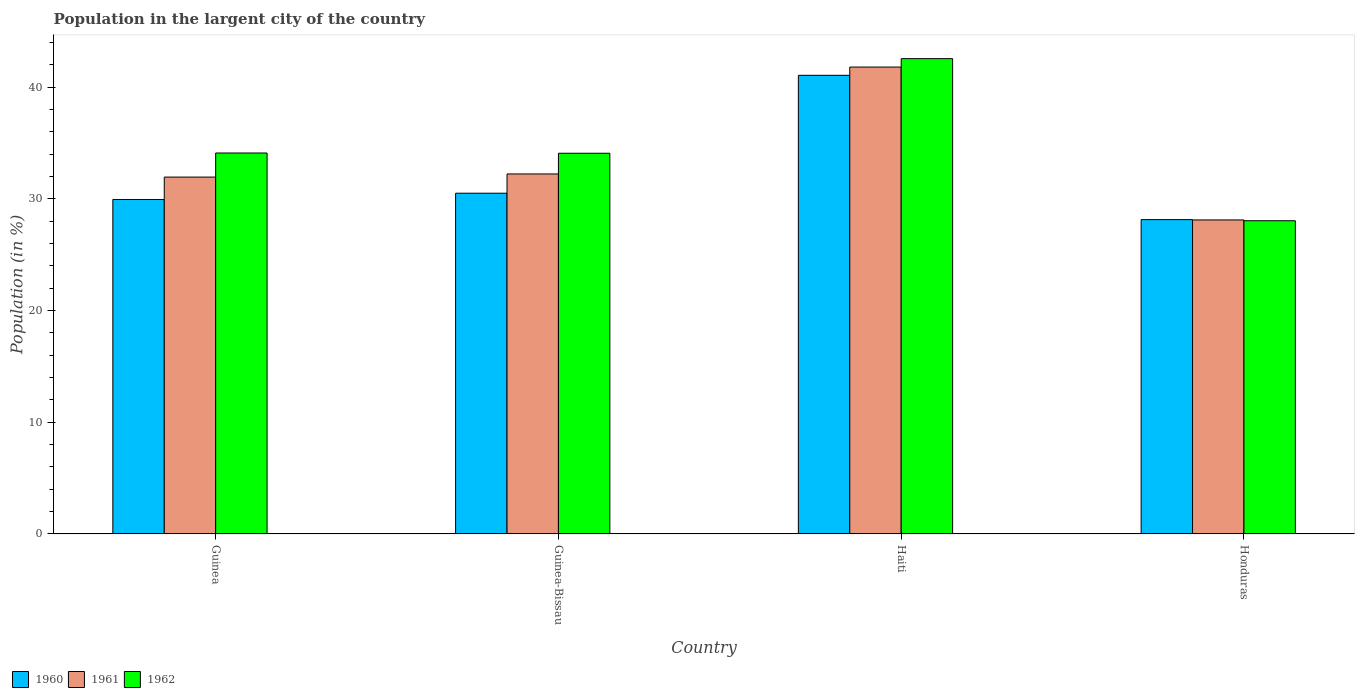Are the number of bars on each tick of the X-axis equal?
Offer a terse response. Yes. How many bars are there on the 1st tick from the left?
Your response must be concise. 3. What is the label of the 4th group of bars from the left?
Your response must be concise. Honduras. What is the percentage of population in the largent city in 1961 in Guinea-Bissau?
Your response must be concise. 32.22. Across all countries, what is the maximum percentage of population in the largent city in 1960?
Your answer should be very brief. 41.05. Across all countries, what is the minimum percentage of population in the largent city in 1960?
Ensure brevity in your answer.  28.14. In which country was the percentage of population in the largent city in 1960 maximum?
Your answer should be very brief. Haiti. In which country was the percentage of population in the largent city in 1960 minimum?
Provide a short and direct response. Honduras. What is the total percentage of population in the largent city in 1960 in the graph?
Give a very brief answer. 129.63. What is the difference between the percentage of population in the largent city in 1962 in Haiti and that in Honduras?
Offer a very short reply. 14.51. What is the difference between the percentage of population in the largent city in 1961 in Haiti and the percentage of population in the largent city in 1962 in Guinea-Bissau?
Give a very brief answer. 7.71. What is the average percentage of population in the largent city in 1960 per country?
Offer a terse response. 32.41. What is the difference between the percentage of population in the largent city of/in 1960 and percentage of population in the largent city of/in 1961 in Guinea-Bissau?
Offer a terse response. -1.72. In how many countries, is the percentage of population in the largent city in 1960 greater than 38 %?
Provide a short and direct response. 1. What is the ratio of the percentage of population in the largent city in 1961 in Guinea-Bissau to that in Haiti?
Offer a very short reply. 0.77. What is the difference between the highest and the second highest percentage of population in the largent city in 1960?
Your answer should be very brief. 11.12. What is the difference between the highest and the lowest percentage of population in the largent city in 1962?
Provide a short and direct response. 14.51. What does the 3rd bar from the left in Honduras represents?
Your response must be concise. 1962. What does the 1st bar from the right in Haiti represents?
Your response must be concise. 1962. How many countries are there in the graph?
Ensure brevity in your answer.  4. Does the graph contain any zero values?
Your answer should be compact. No. How many legend labels are there?
Give a very brief answer. 3. What is the title of the graph?
Keep it short and to the point. Population in the largent city of the country. Does "1965" appear as one of the legend labels in the graph?
Give a very brief answer. No. What is the Population (in %) in 1960 in Guinea?
Offer a terse response. 29.94. What is the Population (in %) of 1961 in Guinea?
Offer a terse response. 31.94. What is the Population (in %) in 1962 in Guinea?
Provide a short and direct response. 34.1. What is the Population (in %) in 1960 in Guinea-Bissau?
Provide a succinct answer. 30.5. What is the Population (in %) of 1961 in Guinea-Bissau?
Offer a terse response. 32.22. What is the Population (in %) of 1962 in Guinea-Bissau?
Ensure brevity in your answer.  34.08. What is the Population (in %) in 1960 in Haiti?
Make the answer very short. 41.05. What is the Population (in %) of 1961 in Haiti?
Your answer should be compact. 41.79. What is the Population (in %) in 1962 in Haiti?
Offer a very short reply. 42.55. What is the Population (in %) in 1960 in Honduras?
Your answer should be very brief. 28.14. What is the Population (in %) in 1961 in Honduras?
Ensure brevity in your answer.  28.11. What is the Population (in %) in 1962 in Honduras?
Offer a terse response. 28.04. Across all countries, what is the maximum Population (in %) of 1960?
Provide a short and direct response. 41.05. Across all countries, what is the maximum Population (in %) in 1961?
Keep it short and to the point. 41.79. Across all countries, what is the maximum Population (in %) in 1962?
Ensure brevity in your answer.  42.55. Across all countries, what is the minimum Population (in %) in 1960?
Provide a short and direct response. 28.14. Across all countries, what is the minimum Population (in %) in 1961?
Provide a succinct answer. 28.11. Across all countries, what is the minimum Population (in %) in 1962?
Offer a terse response. 28.04. What is the total Population (in %) in 1960 in the graph?
Make the answer very short. 129.63. What is the total Population (in %) of 1961 in the graph?
Offer a terse response. 134.07. What is the total Population (in %) in 1962 in the graph?
Give a very brief answer. 138.76. What is the difference between the Population (in %) in 1960 in Guinea and that in Guinea-Bissau?
Provide a short and direct response. -0.56. What is the difference between the Population (in %) of 1961 in Guinea and that in Guinea-Bissau?
Your answer should be very brief. -0.28. What is the difference between the Population (in %) in 1962 in Guinea and that in Guinea-Bissau?
Make the answer very short. 0.02. What is the difference between the Population (in %) of 1960 in Guinea and that in Haiti?
Provide a short and direct response. -11.12. What is the difference between the Population (in %) in 1961 in Guinea and that in Haiti?
Your answer should be very brief. -9.85. What is the difference between the Population (in %) of 1962 in Guinea and that in Haiti?
Your answer should be very brief. -8.45. What is the difference between the Population (in %) of 1960 in Guinea and that in Honduras?
Provide a succinct answer. 1.8. What is the difference between the Population (in %) of 1961 in Guinea and that in Honduras?
Offer a very short reply. 3.84. What is the difference between the Population (in %) in 1962 in Guinea and that in Honduras?
Your answer should be compact. 6.06. What is the difference between the Population (in %) in 1960 in Guinea-Bissau and that in Haiti?
Provide a short and direct response. -10.55. What is the difference between the Population (in %) of 1961 in Guinea-Bissau and that in Haiti?
Offer a very short reply. -9.57. What is the difference between the Population (in %) of 1962 in Guinea-Bissau and that in Haiti?
Make the answer very short. -8.47. What is the difference between the Population (in %) in 1960 in Guinea-Bissau and that in Honduras?
Offer a very short reply. 2.36. What is the difference between the Population (in %) of 1961 in Guinea-Bissau and that in Honduras?
Provide a succinct answer. 4.12. What is the difference between the Population (in %) of 1962 in Guinea-Bissau and that in Honduras?
Offer a terse response. 6.04. What is the difference between the Population (in %) in 1960 in Haiti and that in Honduras?
Provide a succinct answer. 12.92. What is the difference between the Population (in %) of 1961 in Haiti and that in Honduras?
Your answer should be compact. 13.68. What is the difference between the Population (in %) in 1962 in Haiti and that in Honduras?
Offer a very short reply. 14.51. What is the difference between the Population (in %) in 1960 in Guinea and the Population (in %) in 1961 in Guinea-Bissau?
Give a very brief answer. -2.29. What is the difference between the Population (in %) of 1960 in Guinea and the Population (in %) of 1962 in Guinea-Bissau?
Ensure brevity in your answer.  -4.14. What is the difference between the Population (in %) in 1961 in Guinea and the Population (in %) in 1962 in Guinea-Bissau?
Provide a succinct answer. -2.13. What is the difference between the Population (in %) in 1960 in Guinea and the Population (in %) in 1961 in Haiti?
Your answer should be very brief. -11.85. What is the difference between the Population (in %) of 1960 in Guinea and the Population (in %) of 1962 in Haiti?
Provide a succinct answer. -12.61. What is the difference between the Population (in %) in 1961 in Guinea and the Population (in %) in 1962 in Haiti?
Provide a short and direct response. -10.6. What is the difference between the Population (in %) in 1960 in Guinea and the Population (in %) in 1961 in Honduras?
Keep it short and to the point. 1.83. What is the difference between the Population (in %) of 1960 in Guinea and the Population (in %) of 1962 in Honduras?
Your answer should be compact. 1.9. What is the difference between the Population (in %) in 1961 in Guinea and the Population (in %) in 1962 in Honduras?
Provide a succinct answer. 3.91. What is the difference between the Population (in %) in 1960 in Guinea-Bissau and the Population (in %) in 1961 in Haiti?
Provide a succinct answer. -11.29. What is the difference between the Population (in %) of 1960 in Guinea-Bissau and the Population (in %) of 1962 in Haiti?
Offer a very short reply. -12.05. What is the difference between the Population (in %) of 1961 in Guinea-Bissau and the Population (in %) of 1962 in Haiti?
Make the answer very short. -10.32. What is the difference between the Population (in %) in 1960 in Guinea-Bissau and the Population (in %) in 1961 in Honduras?
Ensure brevity in your answer.  2.39. What is the difference between the Population (in %) in 1960 in Guinea-Bissau and the Population (in %) in 1962 in Honduras?
Your answer should be compact. 2.46. What is the difference between the Population (in %) in 1961 in Guinea-Bissau and the Population (in %) in 1962 in Honduras?
Give a very brief answer. 4.19. What is the difference between the Population (in %) of 1960 in Haiti and the Population (in %) of 1961 in Honduras?
Your answer should be compact. 12.95. What is the difference between the Population (in %) in 1960 in Haiti and the Population (in %) in 1962 in Honduras?
Ensure brevity in your answer.  13.02. What is the difference between the Population (in %) of 1961 in Haiti and the Population (in %) of 1962 in Honduras?
Offer a terse response. 13.76. What is the average Population (in %) in 1960 per country?
Give a very brief answer. 32.41. What is the average Population (in %) in 1961 per country?
Your response must be concise. 33.52. What is the average Population (in %) of 1962 per country?
Your answer should be compact. 34.69. What is the difference between the Population (in %) of 1960 and Population (in %) of 1961 in Guinea?
Your answer should be compact. -2.01. What is the difference between the Population (in %) in 1960 and Population (in %) in 1962 in Guinea?
Ensure brevity in your answer.  -4.16. What is the difference between the Population (in %) in 1961 and Population (in %) in 1962 in Guinea?
Provide a short and direct response. -2.15. What is the difference between the Population (in %) in 1960 and Population (in %) in 1961 in Guinea-Bissau?
Give a very brief answer. -1.72. What is the difference between the Population (in %) of 1960 and Population (in %) of 1962 in Guinea-Bissau?
Offer a very short reply. -3.58. What is the difference between the Population (in %) of 1961 and Population (in %) of 1962 in Guinea-Bissau?
Offer a very short reply. -1.85. What is the difference between the Population (in %) in 1960 and Population (in %) in 1961 in Haiti?
Your answer should be compact. -0.74. What is the difference between the Population (in %) in 1960 and Population (in %) in 1962 in Haiti?
Ensure brevity in your answer.  -1.49. What is the difference between the Population (in %) of 1961 and Population (in %) of 1962 in Haiti?
Offer a very short reply. -0.75. What is the difference between the Population (in %) of 1960 and Population (in %) of 1961 in Honduras?
Provide a short and direct response. 0.03. What is the difference between the Population (in %) in 1960 and Population (in %) in 1962 in Honduras?
Provide a short and direct response. 0.1. What is the difference between the Population (in %) in 1961 and Population (in %) in 1962 in Honduras?
Make the answer very short. 0.07. What is the ratio of the Population (in %) of 1960 in Guinea to that in Guinea-Bissau?
Offer a very short reply. 0.98. What is the ratio of the Population (in %) in 1960 in Guinea to that in Haiti?
Provide a short and direct response. 0.73. What is the ratio of the Population (in %) of 1961 in Guinea to that in Haiti?
Your response must be concise. 0.76. What is the ratio of the Population (in %) of 1962 in Guinea to that in Haiti?
Keep it short and to the point. 0.8. What is the ratio of the Population (in %) in 1960 in Guinea to that in Honduras?
Offer a very short reply. 1.06. What is the ratio of the Population (in %) in 1961 in Guinea to that in Honduras?
Keep it short and to the point. 1.14. What is the ratio of the Population (in %) in 1962 in Guinea to that in Honduras?
Offer a very short reply. 1.22. What is the ratio of the Population (in %) of 1960 in Guinea-Bissau to that in Haiti?
Offer a terse response. 0.74. What is the ratio of the Population (in %) in 1961 in Guinea-Bissau to that in Haiti?
Provide a succinct answer. 0.77. What is the ratio of the Population (in %) in 1962 in Guinea-Bissau to that in Haiti?
Your answer should be compact. 0.8. What is the ratio of the Population (in %) in 1960 in Guinea-Bissau to that in Honduras?
Provide a short and direct response. 1.08. What is the ratio of the Population (in %) of 1961 in Guinea-Bissau to that in Honduras?
Offer a very short reply. 1.15. What is the ratio of the Population (in %) of 1962 in Guinea-Bissau to that in Honduras?
Provide a short and direct response. 1.22. What is the ratio of the Population (in %) of 1960 in Haiti to that in Honduras?
Your answer should be compact. 1.46. What is the ratio of the Population (in %) of 1961 in Haiti to that in Honduras?
Give a very brief answer. 1.49. What is the ratio of the Population (in %) of 1962 in Haiti to that in Honduras?
Offer a terse response. 1.52. What is the difference between the highest and the second highest Population (in %) of 1960?
Ensure brevity in your answer.  10.55. What is the difference between the highest and the second highest Population (in %) in 1961?
Your response must be concise. 9.57. What is the difference between the highest and the second highest Population (in %) of 1962?
Your answer should be very brief. 8.45. What is the difference between the highest and the lowest Population (in %) of 1960?
Make the answer very short. 12.92. What is the difference between the highest and the lowest Population (in %) of 1961?
Provide a short and direct response. 13.68. What is the difference between the highest and the lowest Population (in %) in 1962?
Offer a very short reply. 14.51. 